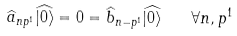Convert formula to latex. <formula><loc_0><loc_0><loc_500><loc_500>\widehat { a } _ { n p ^ { 1 } } \widehat { | 0 \rangle } = 0 = \widehat { b } _ { n - p ^ { 1 } } \widehat { | 0 \rangle } \quad \forall n , p ^ { 1 }</formula> 